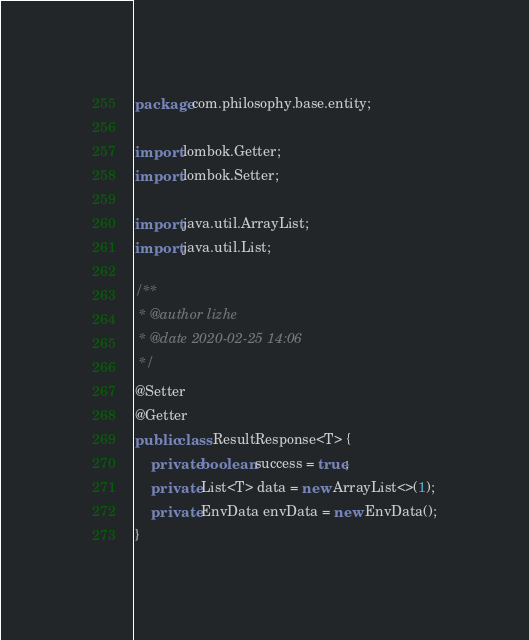<code> <loc_0><loc_0><loc_500><loc_500><_Java_>package com.philosophy.base.entity;

import lombok.Getter;
import lombok.Setter;

import java.util.ArrayList;
import java.util.List;

/**
 * @author lizhe
 * @date 2020-02-25 14:06
 */
@Setter
@Getter
public class ResultResponse<T> {
    private boolean success = true;
    private List<T> data = new ArrayList<>(1);
    private EnvData envData = new EnvData();
}
</code> 